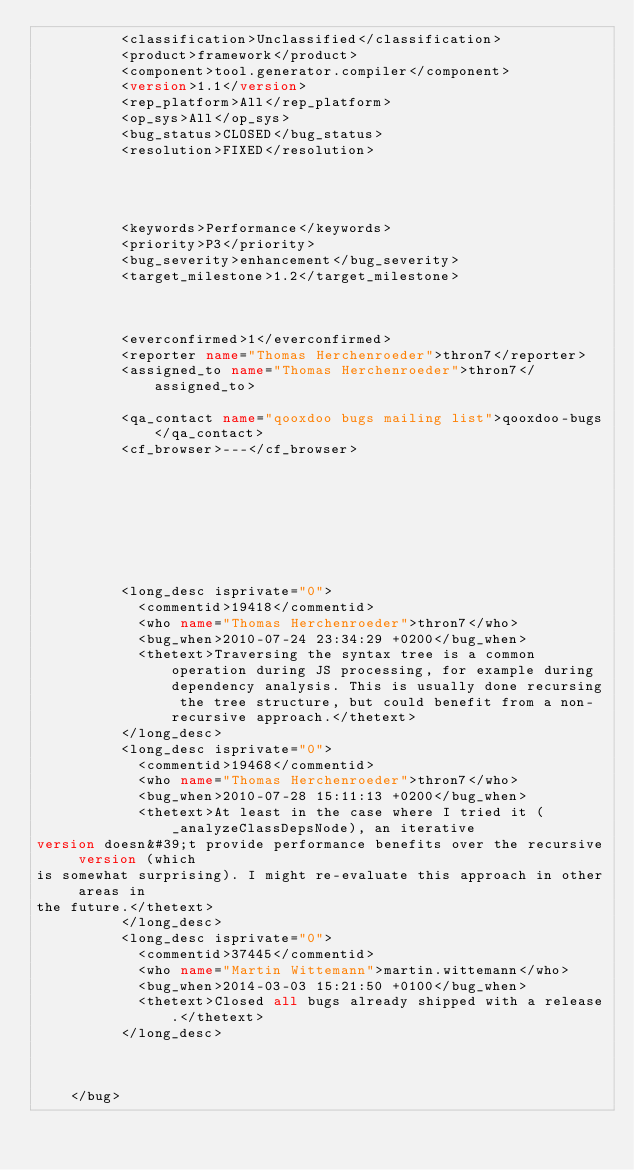<code> <loc_0><loc_0><loc_500><loc_500><_XML_>          <classification>Unclassified</classification>
          <product>framework</product>
          <component>tool.generator.compiler</component>
          <version>1.1</version>
          <rep_platform>All</rep_platform>
          <op_sys>All</op_sys>
          <bug_status>CLOSED</bug_status>
          <resolution>FIXED</resolution>
          
          
          
          
          <keywords>Performance</keywords>
          <priority>P3</priority>
          <bug_severity>enhancement</bug_severity>
          <target_milestone>1.2</target_milestone>
          
          
          
          <everconfirmed>1</everconfirmed>
          <reporter name="Thomas Herchenroeder">thron7</reporter>
          <assigned_to name="Thomas Herchenroeder">thron7</assigned_to>
          
          <qa_contact name="qooxdoo bugs mailing list">qooxdoo-bugs</qa_contact>
          <cf_browser>---</cf_browser>
          

      

      

      

          <long_desc isprivate="0">
            <commentid>19418</commentid>
            <who name="Thomas Herchenroeder">thron7</who>
            <bug_when>2010-07-24 23:34:29 +0200</bug_when>
            <thetext>Traversing the syntax tree is a common operation during JS processing, for example during dependency analysis. This is usually done recursing the tree structure, but could benefit from a non-recursive approach.</thetext>
          </long_desc>
          <long_desc isprivate="0">
            <commentid>19468</commentid>
            <who name="Thomas Herchenroeder">thron7</who>
            <bug_when>2010-07-28 15:11:13 +0200</bug_when>
            <thetext>At least in the case where I tried it (_analyzeClassDepsNode), an iterative 
version doesn&#39;t provide performance benefits over the recursive version (which 
is somewhat surprising). I might re-evaluate this approach in other areas in 
the future.</thetext>
          </long_desc>
          <long_desc isprivate="0">
            <commentid>37445</commentid>
            <who name="Martin Wittemann">martin.wittemann</who>
            <bug_when>2014-03-03 15:21:50 +0100</bug_when>
            <thetext>Closed all bugs already shipped with a release.</thetext>
          </long_desc>
      
      

    </bug></code> 